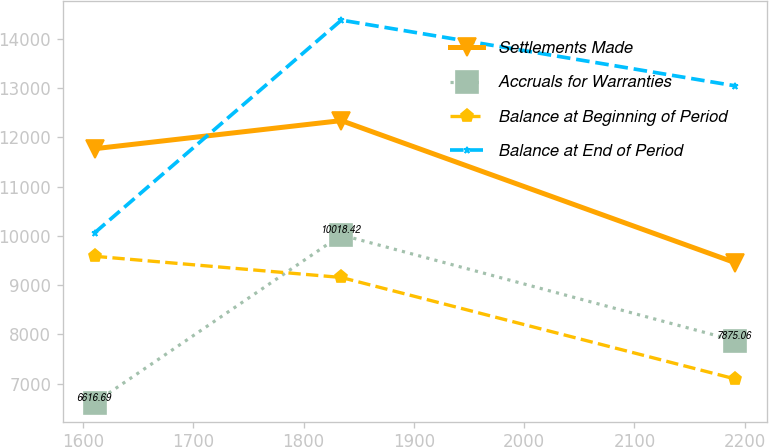Convert chart. <chart><loc_0><loc_0><loc_500><loc_500><line_chart><ecel><fcel>Settlements Made<fcel>Accruals for Warranties<fcel>Balance at Beginning of Period<fcel>Balance at End of Period<nl><fcel>1610.54<fcel>11769.6<fcel>6616.69<fcel>9585.55<fcel>10064.4<nl><fcel>1834.17<fcel>12339.7<fcel>10018.4<fcel>9155.72<fcel>14378.8<nl><fcel>2191.34<fcel>9456.71<fcel>7875.06<fcel>7096.6<fcel>13045.7<nl></chart> 